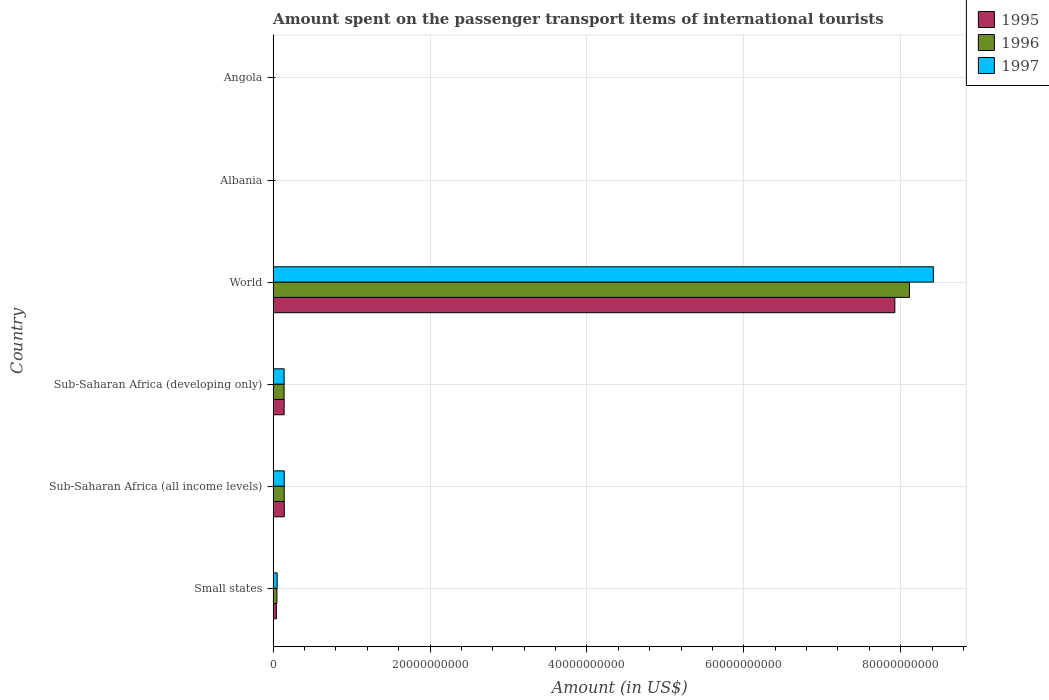How many groups of bars are there?
Your answer should be compact. 6. Are the number of bars on each tick of the Y-axis equal?
Offer a very short reply. Yes. How many bars are there on the 5th tick from the top?
Your response must be concise. 3. What is the label of the 5th group of bars from the top?
Ensure brevity in your answer.  Sub-Saharan Africa (all income levels). What is the amount spent on the passenger transport items of international tourists in 1996 in Sub-Saharan Africa (all income levels)?
Make the answer very short. 1.41e+09. Across all countries, what is the maximum amount spent on the passenger transport items of international tourists in 1996?
Provide a short and direct response. 8.11e+1. Across all countries, what is the minimum amount spent on the passenger transport items of international tourists in 1996?
Ensure brevity in your answer.  1.30e+07. In which country was the amount spent on the passenger transport items of international tourists in 1996 maximum?
Keep it short and to the point. World. In which country was the amount spent on the passenger transport items of international tourists in 1997 minimum?
Give a very brief answer. Albania. What is the total amount spent on the passenger transport items of international tourists in 1997 in the graph?
Offer a terse response. 8.75e+1. What is the difference between the amount spent on the passenger transport items of international tourists in 1997 in Albania and that in Small states?
Keep it short and to the point. -5.07e+08. What is the difference between the amount spent on the passenger transport items of international tourists in 1997 in Sub-Saharan Africa (developing only) and the amount spent on the passenger transport items of international tourists in 1996 in Angola?
Your answer should be very brief. 1.36e+09. What is the average amount spent on the passenger transport items of international tourists in 1995 per country?
Provide a short and direct response. 1.38e+1. What is the difference between the amount spent on the passenger transport items of international tourists in 1997 and amount spent on the passenger transport items of international tourists in 1995 in World?
Give a very brief answer. 4.91e+09. What is the ratio of the amount spent on the passenger transport items of international tourists in 1996 in Sub-Saharan Africa (developing only) to that in World?
Provide a short and direct response. 0.02. What is the difference between the highest and the second highest amount spent on the passenger transport items of international tourists in 1996?
Your response must be concise. 7.97e+1. What is the difference between the highest and the lowest amount spent on the passenger transport items of international tourists in 1996?
Provide a succinct answer. 8.11e+1. In how many countries, is the amount spent on the passenger transport items of international tourists in 1997 greater than the average amount spent on the passenger transport items of international tourists in 1997 taken over all countries?
Offer a very short reply. 1. Are all the bars in the graph horizontal?
Provide a short and direct response. Yes. How many countries are there in the graph?
Provide a succinct answer. 6. What is the difference between two consecutive major ticks on the X-axis?
Provide a short and direct response. 2.00e+1. Are the values on the major ticks of X-axis written in scientific E-notation?
Keep it short and to the point. No. Does the graph contain any zero values?
Offer a terse response. No. Does the graph contain grids?
Make the answer very short. Yes. What is the title of the graph?
Keep it short and to the point. Amount spent on the passenger transport items of international tourists. What is the label or title of the X-axis?
Give a very brief answer. Amount (in US$). What is the Amount (in US$) of 1995 in Small states?
Your answer should be very brief. 4.15e+08. What is the Amount (in US$) of 1996 in Small states?
Provide a short and direct response. 4.85e+08. What is the Amount (in US$) of 1997 in Small states?
Your answer should be very brief. 5.15e+08. What is the Amount (in US$) in 1995 in Sub-Saharan Africa (all income levels)?
Provide a succinct answer. 1.42e+09. What is the Amount (in US$) in 1996 in Sub-Saharan Africa (all income levels)?
Provide a short and direct response. 1.41e+09. What is the Amount (in US$) of 1997 in Sub-Saharan Africa (all income levels)?
Offer a very short reply. 1.42e+09. What is the Amount (in US$) in 1995 in Sub-Saharan Africa (developing only)?
Offer a terse response. 1.41e+09. What is the Amount (in US$) in 1996 in Sub-Saharan Africa (developing only)?
Offer a terse response. 1.40e+09. What is the Amount (in US$) of 1997 in Sub-Saharan Africa (developing only)?
Provide a short and direct response. 1.40e+09. What is the Amount (in US$) in 1995 in World?
Your response must be concise. 7.93e+1. What is the Amount (in US$) of 1996 in World?
Make the answer very short. 8.11e+1. What is the Amount (in US$) in 1997 in World?
Make the answer very short. 8.42e+1. What is the Amount (in US$) in 1995 in Albania?
Ensure brevity in your answer.  1.20e+07. What is the Amount (in US$) of 1996 in Albania?
Your answer should be compact. 1.30e+07. What is the Amount (in US$) of 1995 in Angola?
Provide a short and direct response. 3.78e+07. What is the Amount (in US$) in 1996 in Angola?
Offer a very short reply. 3.74e+07. What is the Amount (in US$) in 1997 in Angola?
Your answer should be very brief. 2.72e+07. Across all countries, what is the maximum Amount (in US$) of 1995?
Offer a very short reply. 7.93e+1. Across all countries, what is the maximum Amount (in US$) of 1996?
Your answer should be very brief. 8.11e+1. Across all countries, what is the maximum Amount (in US$) in 1997?
Your response must be concise. 8.42e+1. Across all countries, what is the minimum Amount (in US$) in 1996?
Offer a very short reply. 1.30e+07. Across all countries, what is the minimum Amount (in US$) in 1997?
Give a very brief answer. 8.00e+06. What is the total Amount (in US$) in 1995 in the graph?
Offer a terse response. 8.25e+1. What is the total Amount (in US$) of 1996 in the graph?
Keep it short and to the point. 8.45e+1. What is the total Amount (in US$) in 1997 in the graph?
Your answer should be compact. 8.75e+1. What is the difference between the Amount (in US$) of 1995 in Small states and that in Sub-Saharan Africa (all income levels)?
Keep it short and to the point. -1.01e+09. What is the difference between the Amount (in US$) of 1996 in Small states and that in Sub-Saharan Africa (all income levels)?
Provide a short and direct response. -9.28e+08. What is the difference between the Amount (in US$) of 1997 in Small states and that in Sub-Saharan Africa (all income levels)?
Your response must be concise. -9.01e+08. What is the difference between the Amount (in US$) in 1995 in Small states and that in Sub-Saharan Africa (developing only)?
Provide a succinct answer. -9.90e+08. What is the difference between the Amount (in US$) of 1996 in Small states and that in Sub-Saharan Africa (developing only)?
Your response must be concise. -9.14e+08. What is the difference between the Amount (in US$) in 1997 in Small states and that in Sub-Saharan Africa (developing only)?
Make the answer very short. -8.87e+08. What is the difference between the Amount (in US$) in 1995 in Small states and that in World?
Keep it short and to the point. -7.88e+1. What is the difference between the Amount (in US$) of 1996 in Small states and that in World?
Provide a short and direct response. -8.06e+1. What is the difference between the Amount (in US$) of 1997 in Small states and that in World?
Your response must be concise. -8.36e+1. What is the difference between the Amount (in US$) of 1995 in Small states and that in Albania?
Give a very brief answer. 4.03e+08. What is the difference between the Amount (in US$) of 1996 in Small states and that in Albania?
Make the answer very short. 4.72e+08. What is the difference between the Amount (in US$) of 1997 in Small states and that in Albania?
Your answer should be very brief. 5.07e+08. What is the difference between the Amount (in US$) in 1995 in Small states and that in Angola?
Offer a very short reply. 3.78e+08. What is the difference between the Amount (in US$) in 1996 in Small states and that in Angola?
Offer a very short reply. 4.48e+08. What is the difference between the Amount (in US$) of 1997 in Small states and that in Angola?
Ensure brevity in your answer.  4.88e+08. What is the difference between the Amount (in US$) in 1995 in Sub-Saharan Africa (all income levels) and that in Sub-Saharan Africa (developing only)?
Ensure brevity in your answer.  1.78e+07. What is the difference between the Amount (in US$) of 1996 in Sub-Saharan Africa (all income levels) and that in Sub-Saharan Africa (developing only)?
Offer a terse response. 1.43e+07. What is the difference between the Amount (in US$) of 1997 in Sub-Saharan Africa (all income levels) and that in Sub-Saharan Africa (developing only)?
Provide a succinct answer. 1.43e+07. What is the difference between the Amount (in US$) of 1995 in Sub-Saharan Africa (all income levels) and that in World?
Provide a short and direct response. -7.78e+1. What is the difference between the Amount (in US$) of 1996 in Sub-Saharan Africa (all income levels) and that in World?
Provide a short and direct response. -7.97e+1. What is the difference between the Amount (in US$) of 1997 in Sub-Saharan Africa (all income levels) and that in World?
Your response must be concise. -8.27e+1. What is the difference between the Amount (in US$) of 1995 in Sub-Saharan Africa (all income levels) and that in Albania?
Provide a short and direct response. 1.41e+09. What is the difference between the Amount (in US$) of 1996 in Sub-Saharan Africa (all income levels) and that in Albania?
Make the answer very short. 1.40e+09. What is the difference between the Amount (in US$) of 1997 in Sub-Saharan Africa (all income levels) and that in Albania?
Offer a very short reply. 1.41e+09. What is the difference between the Amount (in US$) in 1995 in Sub-Saharan Africa (all income levels) and that in Angola?
Offer a terse response. 1.39e+09. What is the difference between the Amount (in US$) in 1996 in Sub-Saharan Africa (all income levels) and that in Angola?
Your response must be concise. 1.38e+09. What is the difference between the Amount (in US$) in 1997 in Sub-Saharan Africa (all income levels) and that in Angola?
Keep it short and to the point. 1.39e+09. What is the difference between the Amount (in US$) of 1995 in Sub-Saharan Africa (developing only) and that in World?
Provide a succinct answer. -7.78e+1. What is the difference between the Amount (in US$) of 1996 in Sub-Saharan Africa (developing only) and that in World?
Offer a terse response. -7.97e+1. What is the difference between the Amount (in US$) in 1997 in Sub-Saharan Africa (developing only) and that in World?
Offer a terse response. -8.28e+1. What is the difference between the Amount (in US$) in 1995 in Sub-Saharan Africa (developing only) and that in Albania?
Give a very brief answer. 1.39e+09. What is the difference between the Amount (in US$) of 1996 in Sub-Saharan Africa (developing only) and that in Albania?
Your answer should be very brief. 1.39e+09. What is the difference between the Amount (in US$) of 1997 in Sub-Saharan Africa (developing only) and that in Albania?
Your answer should be compact. 1.39e+09. What is the difference between the Amount (in US$) in 1995 in Sub-Saharan Africa (developing only) and that in Angola?
Keep it short and to the point. 1.37e+09. What is the difference between the Amount (in US$) in 1996 in Sub-Saharan Africa (developing only) and that in Angola?
Keep it short and to the point. 1.36e+09. What is the difference between the Amount (in US$) of 1997 in Sub-Saharan Africa (developing only) and that in Angola?
Keep it short and to the point. 1.37e+09. What is the difference between the Amount (in US$) of 1995 in World and that in Albania?
Your response must be concise. 7.92e+1. What is the difference between the Amount (in US$) in 1996 in World and that in Albania?
Your response must be concise. 8.11e+1. What is the difference between the Amount (in US$) in 1997 in World and that in Albania?
Provide a short and direct response. 8.42e+1. What is the difference between the Amount (in US$) in 1995 in World and that in Angola?
Keep it short and to the point. 7.92e+1. What is the difference between the Amount (in US$) in 1996 in World and that in Angola?
Keep it short and to the point. 8.11e+1. What is the difference between the Amount (in US$) of 1997 in World and that in Angola?
Ensure brevity in your answer.  8.41e+1. What is the difference between the Amount (in US$) in 1995 in Albania and that in Angola?
Ensure brevity in your answer.  -2.58e+07. What is the difference between the Amount (in US$) in 1996 in Albania and that in Angola?
Your answer should be very brief. -2.44e+07. What is the difference between the Amount (in US$) in 1997 in Albania and that in Angola?
Keep it short and to the point. -1.92e+07. What is the difference between the Amount (in US$) in 1995 in Small states and the Amount (in US$) in 1996 in Sub-Saharan Africa (all income levels)?
Offer a very short reply. -9.98e+08. What is the difference between the Amount (in US$) in 1995 in Small states and the Amount (in US$) in 1997 in Sub-Saharan Africa (all income levels)?
Offer a very short reply. -1.00e+09. What is the difference between the Amount (in US$) in 1996 in Small states and the Amount (in US$) in 1997 in Sub-Saharan Africa (all income levels)?
Keep it short and to the point. -9.31e+08. What is the difference between the Amount (in US$) of 1995 in Small states and the Amount (in US$) of 1996 in Sub-Saharan Africa (developing only)?
Your answer should be compact. -9.84e+08. What is the difference between the Amount (in US$) in 1995 in Small states and the Amount (in US$) in 1997 in Sub-Saharan Africa (developing only)?
Your answer should be compact. -9.86e+08. What is the difference between the Amount (in US$) in 1996 in Small states and the Amount (in US$) in 1997 in Sub-Saharan Africa (developing only)?
Your answer should be very brief. -9.17e+08. What is the difference between the Amount (in US$) of 1995 in Small states and the Amount (in US$) of 1996 in World?
Give a very brief answer. -8.07e+1. What is the difference between the Amount (in US$) of 1995 in Small states and the Amount (in US$) of 1997 in World?
Give a very brief answer. -8.37e+1. What is the difference between the Amount (in US$) of 1996 in Small states and the Amount (in US$) of 1997 in World?
Your answer should be compact. -8.37e+1. What is the difference between the Amount (in US$) of 1995 in Small states and the Amount (in US$) of 1996 in Albania?
Keep it short and to the point. 4.02e+08. What is the difference between the Amount (in US$) of 1995 in Small states and the Amount (in US$) of 1997 in Albania?
Give a very brief answer. 4.07e+08. What is the difference between the Amount (in US$) in 1996 in Small states and the Amount (in US$) in 1997 in Albania?
Make the answer very short. 4.77e+08. What is the difference between the Amount (in US$) of 1995 in Small states and the Amount (in US$) of 1996 in Angola?
Keep it short and to the point. 3.78e+08. What is the difference between the Amount (in US$) of 1995 in Small states and the Amount (in US$) of 1997 in Angola?
Your answer should be compact. 3.88e+08. What is the difference between the Amount (in US$) of 1996 in Small states and the Amount (in US$) of 1997 in Angola?
Offer a terse response. 4.58e+08. What is the difference between the Amount (in US$) of 1995 in Sub-Saharan Africa (all income levels) and the Amount (in US$) of 1996 in Sub-Saharan Africa (developing only)?
Make the answer very short. 2.39e+07. What is the difference between the Amount (in US$) in 1995 in Sub-Saharan Africa (all income levels) and the Amount (in US$) in 1997 in Sub-Saharan Africa (developing only)?
Offer a very short reply. 2.14e+07. What is the difference between the Amount (in US$) of 1996 in Sub-Saharan Africa (all income levels) and the Amount (in US$) of 1997 in Sub-Saharan Africa (developing only)?
Offer a terse response. 1.18e+07. What is the difference between the Amount (in US$) in 1995 in Sub-Saharan Africa (all income levels) and the Amount (in US$) in 1996 in World?
Keep it short and to the point. -7.97e+1. What is the difference between the Amount (in US$) in 1995 in Sub-Saharan Africa (all income levels) and the Amount (in US$) in 1997 in World?
Provide a short and direct response. -8.27e+1. What is the difference between the Amount (in US$) of 1996 in Sub-Saharan Africa (all income levels) and the Amount (in US$) of 1997 in World?
Ensure brevity in your answer.  -8.27e+1. What is the difference between the Amount (in US$) of 1995 in Sub-Saharan Africa (all income levels) and the Amount (in US$) of 1996 in Albania?
Your answer should be very brief. 1.41e+09. What is the difference between the Amount (in US$) of 1995 in Sub-Saharan Africa (all income levels) and the Amount (in US$) of 1997 in Albania?
Provide a succinct answer. 1.42e+09. What is the difference between the Amount (in US$) of 1996 in Sub-Saharan Africa (all income levels) and the Amount (in US$) of 1997 in Albania?
Make the answer very short. 1.41e+09. What is the difference between the Amount (in US$) in 1995 in Sub-Saharan Africa (all income levels) and the Amount (in US$) in 1996 in Angola?
Your answer should be very brief. 1.39e+09. What is the difference between the Amount (in US$) in 1995 in Sub-Saharan Africa (all income levels) and the Amount (in US$) in 1997 in Angola?
Offer a very short reply. 1.40e+09. What is the difference between the Amount (in US$) in 1996 in Sub-Saharan Africa (all income levels) and the Amount (in US$) in 1997 in Angola?
Offer a very short reply. 1.39e+09. What is the difference between the Amount (in US$) of 1995 in Sub-Saharan Africa (developing only) and the Amount (in US$) of 1996 in World?
Ensure brevity in your answer.  -7.97e+1. What is the difference between the Amount (in US$) in 1995 in Sub-Saharan Africa (developing only) and the Amount (in US$) in 1997 in World?
Make the answer very short. -8.28e+1. What is the difference between the Amount (in US$) of 1996 in Sub-Saharan Africa (developing only) and the Amount (in US$) of 1997 in World?
Make the answer very short. -8.28e+1. What is the difference between the Amount (in US$) in 1995 in Sub-Saharan Africa (developing only) and the Amount (in US$) in 1996 in Albania?
Ensure brevity in your answer.  1.39e+09. What is the difference between the Amount (in US$) of 1995 in Sub-Saharan Africa (developing only) and the Amount (in US$) of 1997 in Albania?
Provide a short and direct response. 1.40e+09. What is the difference between the Amount (in US$) in 1996 in Sub-Saharan Africa (developing only) and the Amount (in US$) in 1997 in Albania?
Provide a short and direct response. 1.39e+09. What is the difference between the Amount (in US$) of 1995 in Sub-Saharan Africa (developing only) and the Amount (in US$) of 1996 in Angola?
Your response must be concise. 1.37e+09. What is the difference between the Amount (in US$) of 1995 in Sub-Saharan Africa (developing only) and the Amount (in US$) of 1997 in Angola?
Your response must be concise. 1.38e+09. What is the difference between the Amount (in US$) in 1996 in Sub-Saharan Africa (developing only) and the Amount (in US$) in 1997 in Angola?
Offer a terse response. 1.37e+09. What is the difference between the Amount (in US$) of 1995 in World and the Amount (in US$) of 1996 in Albania?
Give a very brief answer. 7.92e+1. What is the difference between the Amount (in US$) of 1995 in World and the Amount (in US$) of 1997 in Albania?
Your response must be concise. 7.92e+1. What is the difference between the Amount (in US$) in 1996 in World and the Amount (in US$) in 1997 in Albania?
Your answer should be very brief. 8.11e+1. What is the difference between the Amount (in US$) in 1995 in World and the Amount (in US$) in 1996 in Angola?
Your response must be concise. 7.92e+1. What is the difference between the Amount (in US$) in 1995 in World and the Amount (in US$) in 1997 in Angola?
Provide a short and direct response. 7.92e+1. What is the difference between the Amount (in US$) in 1996 in World and the Amount (in US$) in 1997 in Angola?
Keep it short and to the point. 8.11e+1. What is the difference between the Amount (in US$) in 1995 in Albania and the Amount (in US$) in 1996 in Angola?
Offer a terse response. -2.54e+07. What is the difference between the Amount (in US$) of 1995 in Albania and the Amount (in US$) of 1997 in Angola?
Offer a terse response. -1.52e+07. What is the difference between the Amount (in US$) in 1996 in Albania and the Amount (in US$) in 1997 in Angola?
Offer a very short reply. -1.42e+07. What is the average Amount (in US$) in 1995 per country?
Your answer should be very brief. 1.38e+1. What is the average Amount (in US$) in 1996 per country?
Your answer should be very brief. 1.41e+1. What is the average Amount (in US$) of 1997 per country?
Your answer should be very brief. 1.46e+1. What is the difference between the Amount (in US$) of 1995 and Amount (in US$) of 1996 in Small states?
Offer a terse response. -6.97e+07. What is the difference between the Amount (in US$) of 1995 and Amount (in US$) of 1997 in Small states?
Your answer should be compact. -9.94e+07. What is the difference between the Amount (in US$) in 1996 and Amount (in US$) in 1997 in Small states?
Provide a short and direct response. -2.97e+07. What is the difference between the Amount (in US$) in 1995 and Amount (in US$) in 1996 in Sub-Saharan Africa (all income levels)?
Provide a succinct answer. 9.58e+06. What is the difference between the Amount (in US$) in 1995 and Amount (in US$) in 1997 in Sub-Saharan Africa (all income levels)?
Keep it short and to the point. 7.08e+06. What is the difference between the Amount (in US$) of 1996 and Amount (in US$) of 1997 in Sub-Saharan Africa (all income levels)?
Give a very brief answer. -2.51e+06. What is the difference between the Amount (in US$) of 1995 and Amount (in US$) of 1996 in Sub-Saharan Africa (developing only)?
Your answer should be very brief. 6.01e+06. What is the difference between the Amount (in US$) of 1995 and Amount (in US$) of 1997 in Sub-Saharan Africa (developing only)?
Give a very brief answer. 3.52e+06. What is the difference between the Amount (in US$) of 1996 and Amount (in US$) of 1997 in Sub-Saharan Africa (developing only)?
Your answer should be compact. -2.49e+06. What is the difference between the Amount (in US$) of 1995 and Amount (in US$) of 1996 in World?
Ensure brevity in your answer.  -1.87e+09. What is the difference between the Amount (in US$) in 1995 and Amount (in US$) in 1997 in World?
Provide a short and direct response. -4.91e+09. What is the difference between the Amount (in US$) of 1996 and Amount (in US$) of 1997 in World?
Your answer should be very brief. -3.04e+09. What is the difference between the Amount (in US$) of 1995 and Amount (in US$) of 1996 in Albania?
Offer a very short reply. -1.00e+06. What is the difference between the Amount (in US$) of 1995 and Amount (in US$) of 1997 in Albania?
Offer a terse response. 4.00e+06. What is the difference between the Amount (in US$) of 1995 and Amount (in US$) of 1996 in Angola?
Provide a short and direct response. 4.50e+05. What is the difference between the Amount (in US$) in 1995 and Amount (in US$) in 1997 in Angola?
Make the answer very short. 1.06e+07. What is the difference between the Amount (in US$) of 1996 and Amount (in US$) of 1997 in Angola?
Provide a short and direct response. 1.02e+07. What is the ratio of the Amount (in US$) in 1995 in Small states to that in Sub-Saharan Africa (all income levels)?
Make the answer very short. 0.29. What is the ratio of the Amount (in US$) of 1996 in Small states to that in Sub-Saharan Africa (all income levels)?
Offer a very short reply. 0.34. What is the ratio of the Amount (in US$) in 1997 in Small states to that in Sub-Saharan Africa (all income levels)?
Provide a short and direct response. 0.36. What is the ratio of the Amount (in US$) of 1995 in Small states to that in Sub-Saharan Africa (developing only)?
Offer a terse response. 0.3. What is the ratio of the Amount (in US$) of 1996 in Small states to that in Sub-Saharan Africa (developing only)?
Give a very brief answer. 0.35. What is the ratio of the Amount (in US$) in 1997 in Small states to that in Sub-Saharan Africa (developing only)?
Give a very brief answer. 0.37. What is the ratio of the Amount (in US$) of 1995 in Small states to that in World?
Give a very brief answer. 0.01. What is the ratio of the Amount (in US$) of 1996 in Small states to that in World?
Ensure brevity in your answer.  0.01. What is the ratio of the Amount (in US$) of 1997 in Small states to that in World?
Your answer should be compact. 0.01. What is the ratio of the Amount (in US$) in 1995 in Small states to that in Albania?
Offer a terse response. 34.62. What is the ratio of the Amount (in US$) of 1996 in Small states to that in Albania?
Provide a short and direct response. 37.32. What is the ratio of the Amount (in US$) in 1997 in Small states to that in Albania?
Ensure brevity in your answer.  64.36. What is the ratio of the Amount (in US$) in 1995 in Small states to that in Angola?
Offer a terse response. 10.99. What is the ratio of the Amount (in US$) of 1996 in Small states to that in Angola?
Give a very brief answer. 12.98. What is the ratio of the Amount (in US$) in 1997 in Small states to that in Angola?
Provide a succinct answer. 18.93. What is the ratio of the Amount (in US$) of 1995 in Sub-Saharan Africa (all income levels) to that in Sub-Saharan Africa (developing only)?
Make the answer very short. 1.01. What is the ratio of the Amount (in US$) in 1996 in Sub-Saharan Africa (all income levels) to that in Sub-Saharan Africa (developing only)?
Your answer should be very brief. 1.01. What is the ratio of the Amount (in US$) in 1997 in Sub-Saharan Africa (all income levels) to that in Sub-Saharan Africa (developing only)?
Keep it short and to the point. 1.01. What is the ratio of the Amount (in US$) of 1995 in Sub-Saharan Africa (all income levels) to that in World?
Give a very brief answer. 0.02. What is the ratio of the Amount (in US$) in 1996 in Sub-Saharan Africa (all income levels) to that in World?
Offer a terse response. 0.02. What is the ratio of the Amount (in US$) of 1997 in Sub-Saharan Africa (all income levels) to that in World?
Your answer should be compact. 0.02. What is the ratio of the Amount (in US$) of 1995 in Sub-Saharan Africa (all income levels) to that in Albania?
Provide a succinct answer. 118.6. What is the ratio of the Amount (in US$) of 1996 in Sub-Saharan Africa (all income levels) to that in Albania?
Provide a succinct answer. 108.74. What is the ratio of the Amount (in US$) of 1997 in Sub-Saharan Africa (all income levels) to that in Albania?
Make the answer very short. 177.02. What is the ratio of the Amount (in US$) of 1995 in Sub-Saharan Africa (all income levels) to that in Angola?
Your answer should be compact. 37.63. What is the ratio of the Amount (in US$) of 1996 in Sub-Saharan Africa (all income levels) to that in Angola?
Offer a very short reply. 37.83. What is the ratio of the Amount (in US$) of 1997 in Sub-Saharan Africa (all income levels) to that in Angola?
Keep it short and to the point. 52.06. What is the ratio of the Amount (in US$) of 1995 in Sub-Saharan Africa (developing only) to that in World?
Your answer should be compact. 0.02. What is the ratio of the Amount (in US$) of 1996 in Sub-Saharan Africa (developing only) to that in World?
Your response must be concise. 0.02. What is the ratio of the Amount (in US$) in 1997 in Sub-Saharan Africa (developing only) to that in World?
Ensure brevity in your answer.  0.02. What is the ratio of the Amount (in US$) of 1995 in Sub-Saharan Africa (developing only) to that in Albania?
Your answer should be very brief. 117.11. What is the ratio of the Amount (in US$) of 1996 in Sub-Saharan Africa (developing only) to that in Albania?
Offer a very short reply. 107.64. What is the ratio of the Amount (in US$) of 1997 in Sub-Saharan Africa (developing only) to that in Albania?
Your response must be concise. 175.23. What is the ratio of the Amount (in US$) in 1995 in Sub-Saharan Africa (developing only) to that in Angola?
Offer a very short reply. 37.16. What is the ratio of the Amount (in US$) of 1996 in Sub-Saharan Africa (developing only) to that in Angola?
Keep it short and to the point. 37.45. What is the ratio of the Amount (in US$) in 1997 in Sub-Saharan Africa (developing only) to that in Angola?
Your answer should be compact. 51.54. What is the ratio of the Amount (in US$) in 1995 in World to that in Albania?
Offer a very short reply. 6604.42. What is the ratio of the Amount (in US$) in 1996 in World to that in Albania?
Ensure brevity in your answer.  6239.88. What is the ratio of the Amount (in US$) in 1997 in World to that in Albania?
Your answer should be very brief. 1.05e+04. What is the ratio of the Amount (in US$) of 1995 in World to that in Angola?
Provide a succinct answer. 2095.59. What is the ratio of the Amount (in US$) of 1996 in World to that in Angola?
Ensure brevity in your answer.  2170.74. What is the ratio of the Amount (in US$) of 1997 in World to that in Angola?
Offer a very short reply. 3094.22. What is the ratio of the Amount (in US$) in 1995 in Albania to that in Angola?
Ensure brevity in your answer.  0.32. What is the ratio of the Amount (in US$) of 1996 in Albania to that in Angola?
Give a very brief answer. 0.35. What is the ratio of the Amount (in US$) in 1997 in Albania to that in Angola?
Your response must be concise. 0.29. What is the difference between the highest and the second highest Amount (in US$) of 1995?
Offer a very short reply. 7.78e+1. What is the difference between the highest and the second highest Amount (in US$) of 1996?
Ensure brevity in your answer.  7.97e+1. What is the difference between the highest and the second highest Amount (in US$) in 1997?
Your response must be concise. 8.27e+1. What is the difference between the highest and the lowest Amount (in US$) in 1995?
Offer a terse response. 7.92e+1. What is the difference between the highest and the lowest Amount (in US$) of 1996?
Your answer should be compact. 8.11e+1. What is the difference between the highest and the lowest Amount (in US$) of 1997?
Provide a succinct answer. 8.42e+1. 